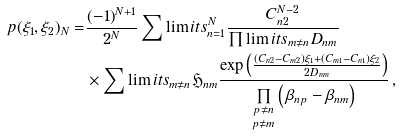Convert formula to latex. <formula><loc_0><loc_0><loc_500><loc_500>p ( \xi _ { 1 } , \xi _ { 2 } ) _ { N } = & \frac { ( - 1 ) ^ { N + 1 } } { 2 ^ { N } } \sum \lim i t s _ { n = 1 } ^ { N } \frac { C _ { n 2 } ^ { N - 2 } } { \prod \lim i t s _ { m \neq n } D _ { n m } } \\ & \times \sum \lim i t s _ { m \neq n } \mathfrak { H } _ { n m } \frac { \exp \left ( \frac { ( C _ { n 2 } - C _ { m 2 } ) \xi _ { 1 } + ( C _ { m 1 } - C _ { n 1 } ) \xi _ { 2 } } { 2 D _ { n m } } \right ) } { \underset { p \neq m } { \underset { p \neq n } { \prod } } \left ( \, \beta _ { n p } - \beta _ { n m } \right ) } \, ,</formula> 